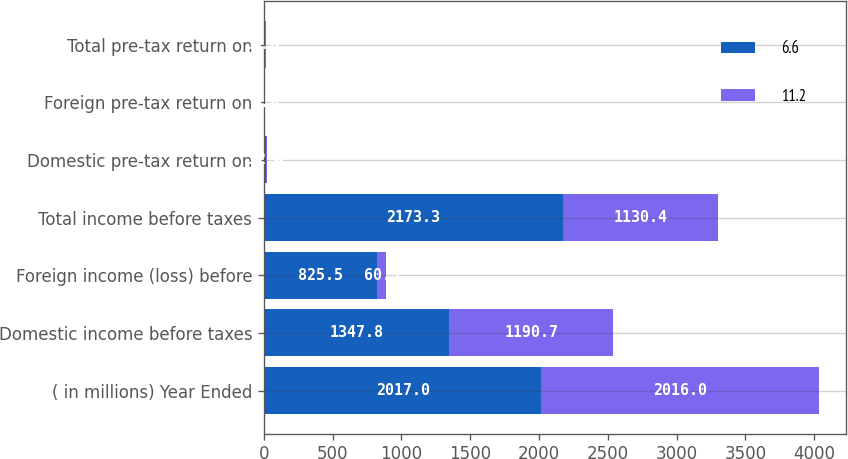<chart> <loc_0><loc_0><loc_500><loc_500><stacked_bar_chart><ecel><fcel>( in millions) Year Ended<fcel>Domestic income before taxes<fcel>Foreign income (loss) before<fcel>Total income before taxes<fcel>Domestic pre-tax return on<fcel>Foreign pre-tax return on<fcel>Total pre-tax return on<nl><fcel>6.6<fcel>2017<fcel>1347.8<fcel>825.5<fcel>2173.3<fcel>12.8<fcel>9.2<fcel>11.2<nl><fcel>11.2<fcel>2016<fcel>1190.7<fcel>60.3<fcel>1130.4<fcel>12.8<fcel>0.8<fcel>6.6<nl></chart> 